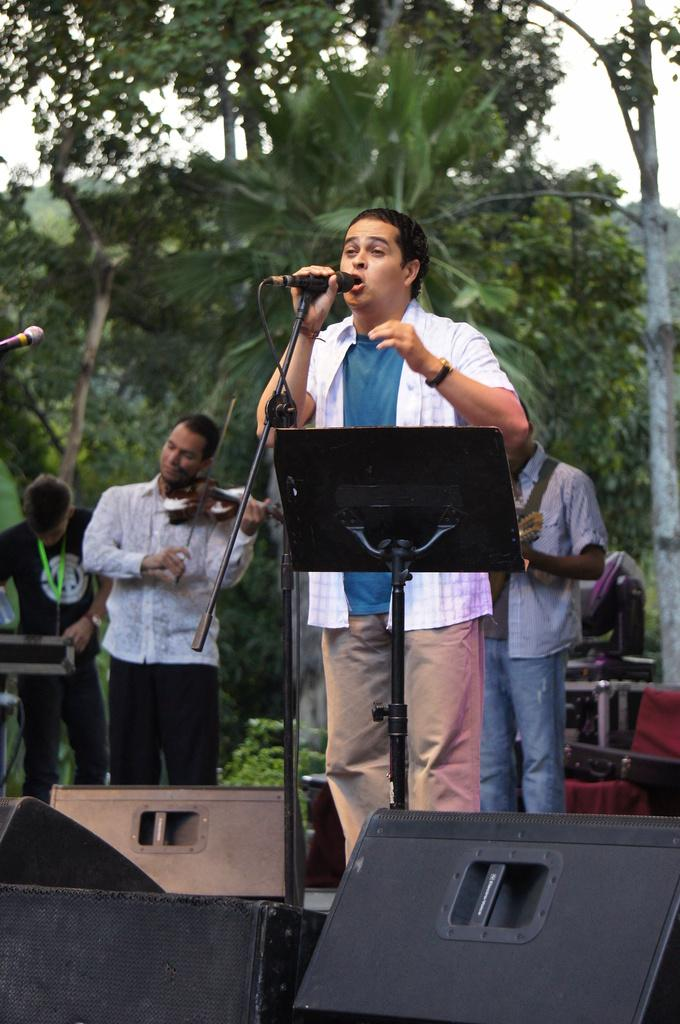What is the main activity of the person in the center of the image? The person in the center of the image is singing. What tool is the person using to amplify their voice? The person is using a microphone. What are the people in the background of the image doing? The people in the background of the image are playing musical instruments. What type of natural scenery can be seen in the background of the image? There are trees visible in the background of the image. What type of poison is the person using to enhance their singing voice in the image? There is no mention of poison in the image, and the person is using a microphone to amplify their voice. 